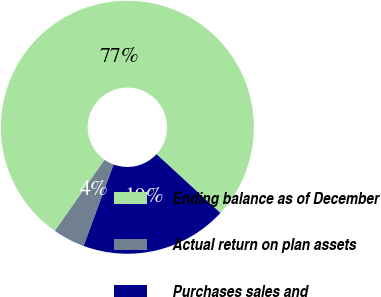Convert chart. <chart><loc_0><loc_0><loc_500><loc_500><pie_chart><fcel>Ending balance as of December<fcel>Actual return on plan assets<fcel>Purchases sales and<nl><fcel>77.14%<fcel>4.1%<fcel>18.76%<nl></chart> 